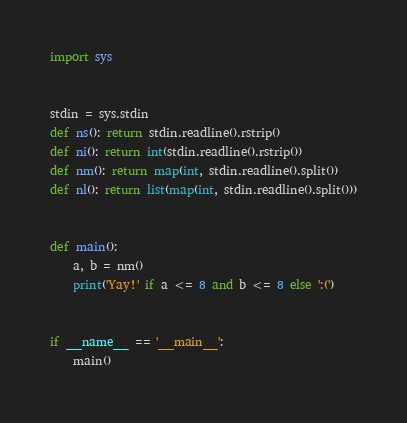<code> <loc_0><loc_0><loc_500><loc_500><_Python_>import sys


stdin = sys.stdin
def ns(): return stdin.readline().rstrip()
def ni(): return int(stdin.readline().rstrip())
def nm(): return map(int, stdin.readline().split())
def nl(): return list(map(int, stdin.readline().split()))


def main():
    a, b = nm()
    print('Yay!' if a <= 8 and b <= 8 else ':(')


if __name__ == '__main__':
    main()
</code> 